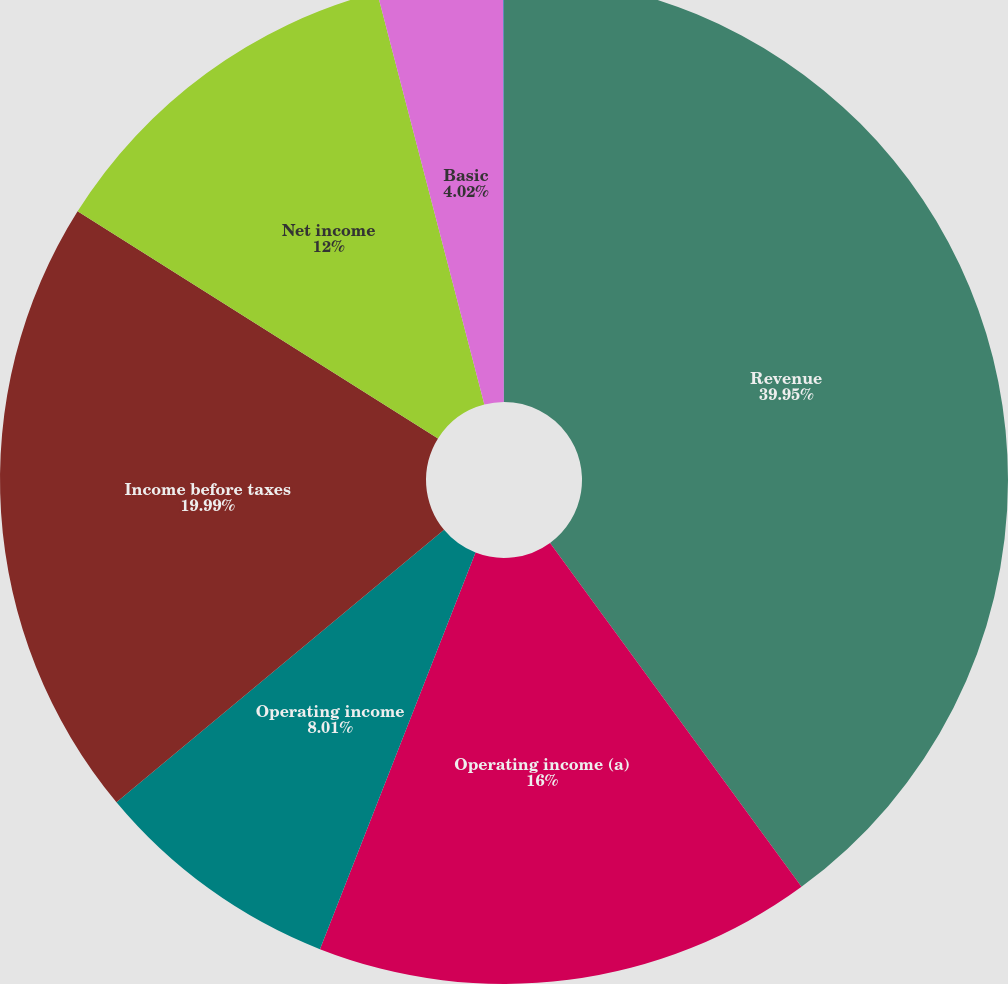<chart> <loc_0><loc_0><loc_500><loc_500><pie_chart><fcel>Revenue<fcel>Operating income (a)<fcel>Operating income<fcel>Income before taxes<fcel>Net income<fcel>Basic<fcel>Diluted<nl><fcel>39.95%<fcel>16.0%<fcel>8.01%<fcel>19.99%<fcel>12.0%<fcel>4.02%<fcel>0.03%<nl></chart> 